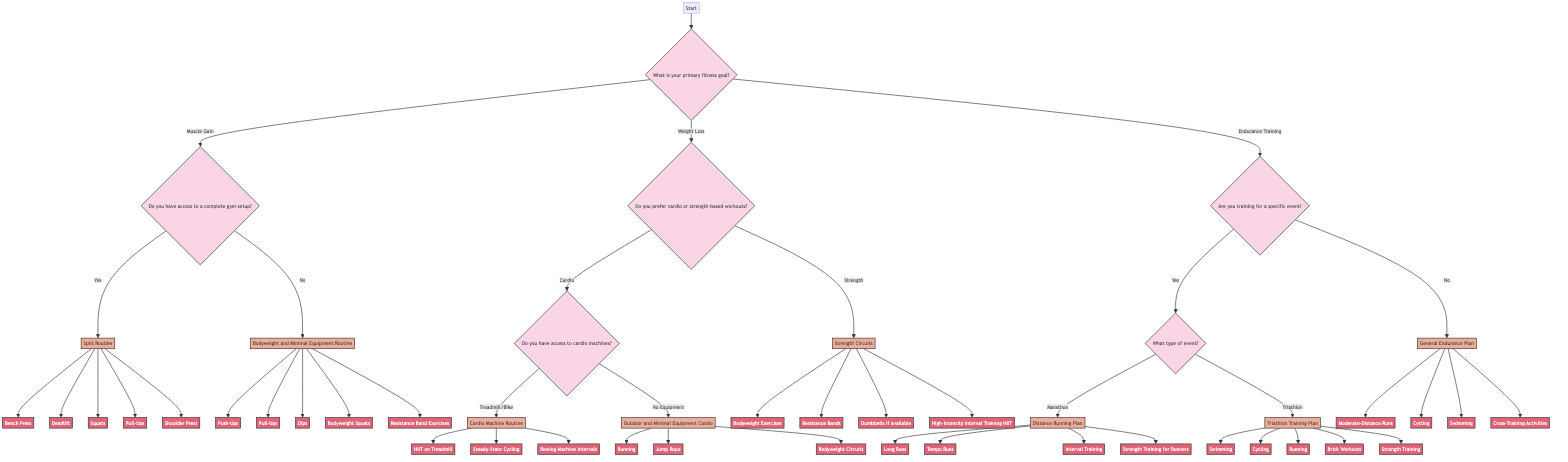What is the first question asked in the diagram? The first question in the diagram is asked at the "Start" node, which inquires about the primary fitness goal of the user.
Answer: What is your primary fitness goal? How many primary fitness goals are presented in the diagram? The diagram presents three primary fitness goals: Muscle Gain, Weight Loss, and Endurance Training.
Answer: Three If someone chooses "Strength" under "Weight Loss," what is their workout plan? The path would follow the option "Strength" under "Weight Loss," leading directly to the "Strength Circuits" workout plan.
Answer: Strength Circuits What activities are included in the "Distance Running Plan"? Following the "Distance Running Plan" node from "Marathon," the activities include Long Runs, Tempo Runs, Interval Training, and Strength Training for Runners.
Answer: Long Runs, Tempo Runs, Interval Training, Strength Training for Runners What are the two options presented after choosing "Endurance Training"? After "Endurance Training," the next question asks if one is training for a specific event, leading to the options "Yes" or "No."
Answer: Yes or No If a person answers "No" to having access to cardio machines, what is their workout plan? The answer "No" leads to the workout plan called "Outdoor and Minimal Equipment Cardio."
Answer: Outdoor and Minimal Equipment Cardio What is the relationship between "Muscle Gain" and "Bodyweight and Minimal Equipment Routine"? "Muscle Gain" is directly connected to the question about gym setup; if the answer is "No," the path leads to the "Bodyweight and Minimal Equipment Routine."
Answer: "Muscle Gain" → "No" → "Bodyweight and Minimal Equipment Routine" What type of activities are included in "General Endurance Plan"? The "General Endurance Plan" includes activities such as Moderate-Distance Runs, Cycling, Swimming, and Cross-Training Activities.
Answer: Moderate-Distance Runs, Cycling, Swimming, Cross-Training Activities 